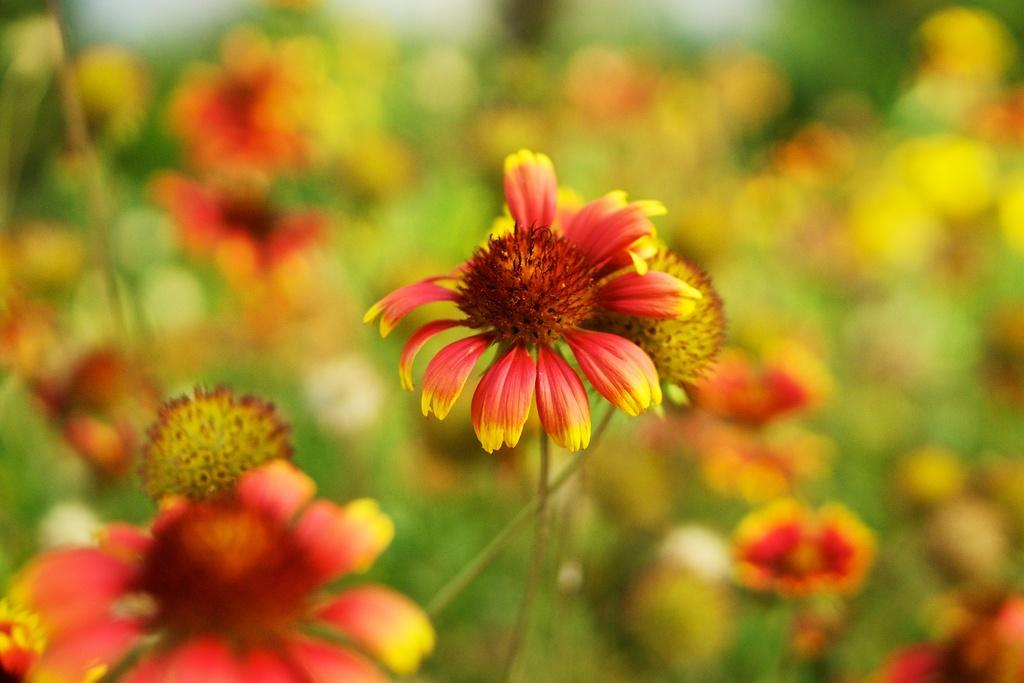What type of living organisms can be seen in the image? There are flowers in the image. Can you describe the background of the image? The background of the image is blurred. How many bears can be seen interacting with the flowers in the image? There are no bears present in the image; it features flowers and a blurred background. What type of structure is visible in the image? There is no structure visible in the image; it features flowers and a blurred background. 